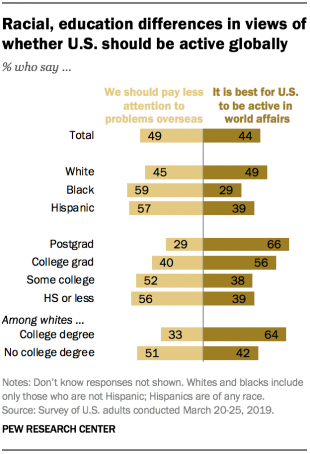Point out several critical features in this image. The color of the bars on the right is darker than the color of the bars on the left. There are 8 bars that have values above 50. 